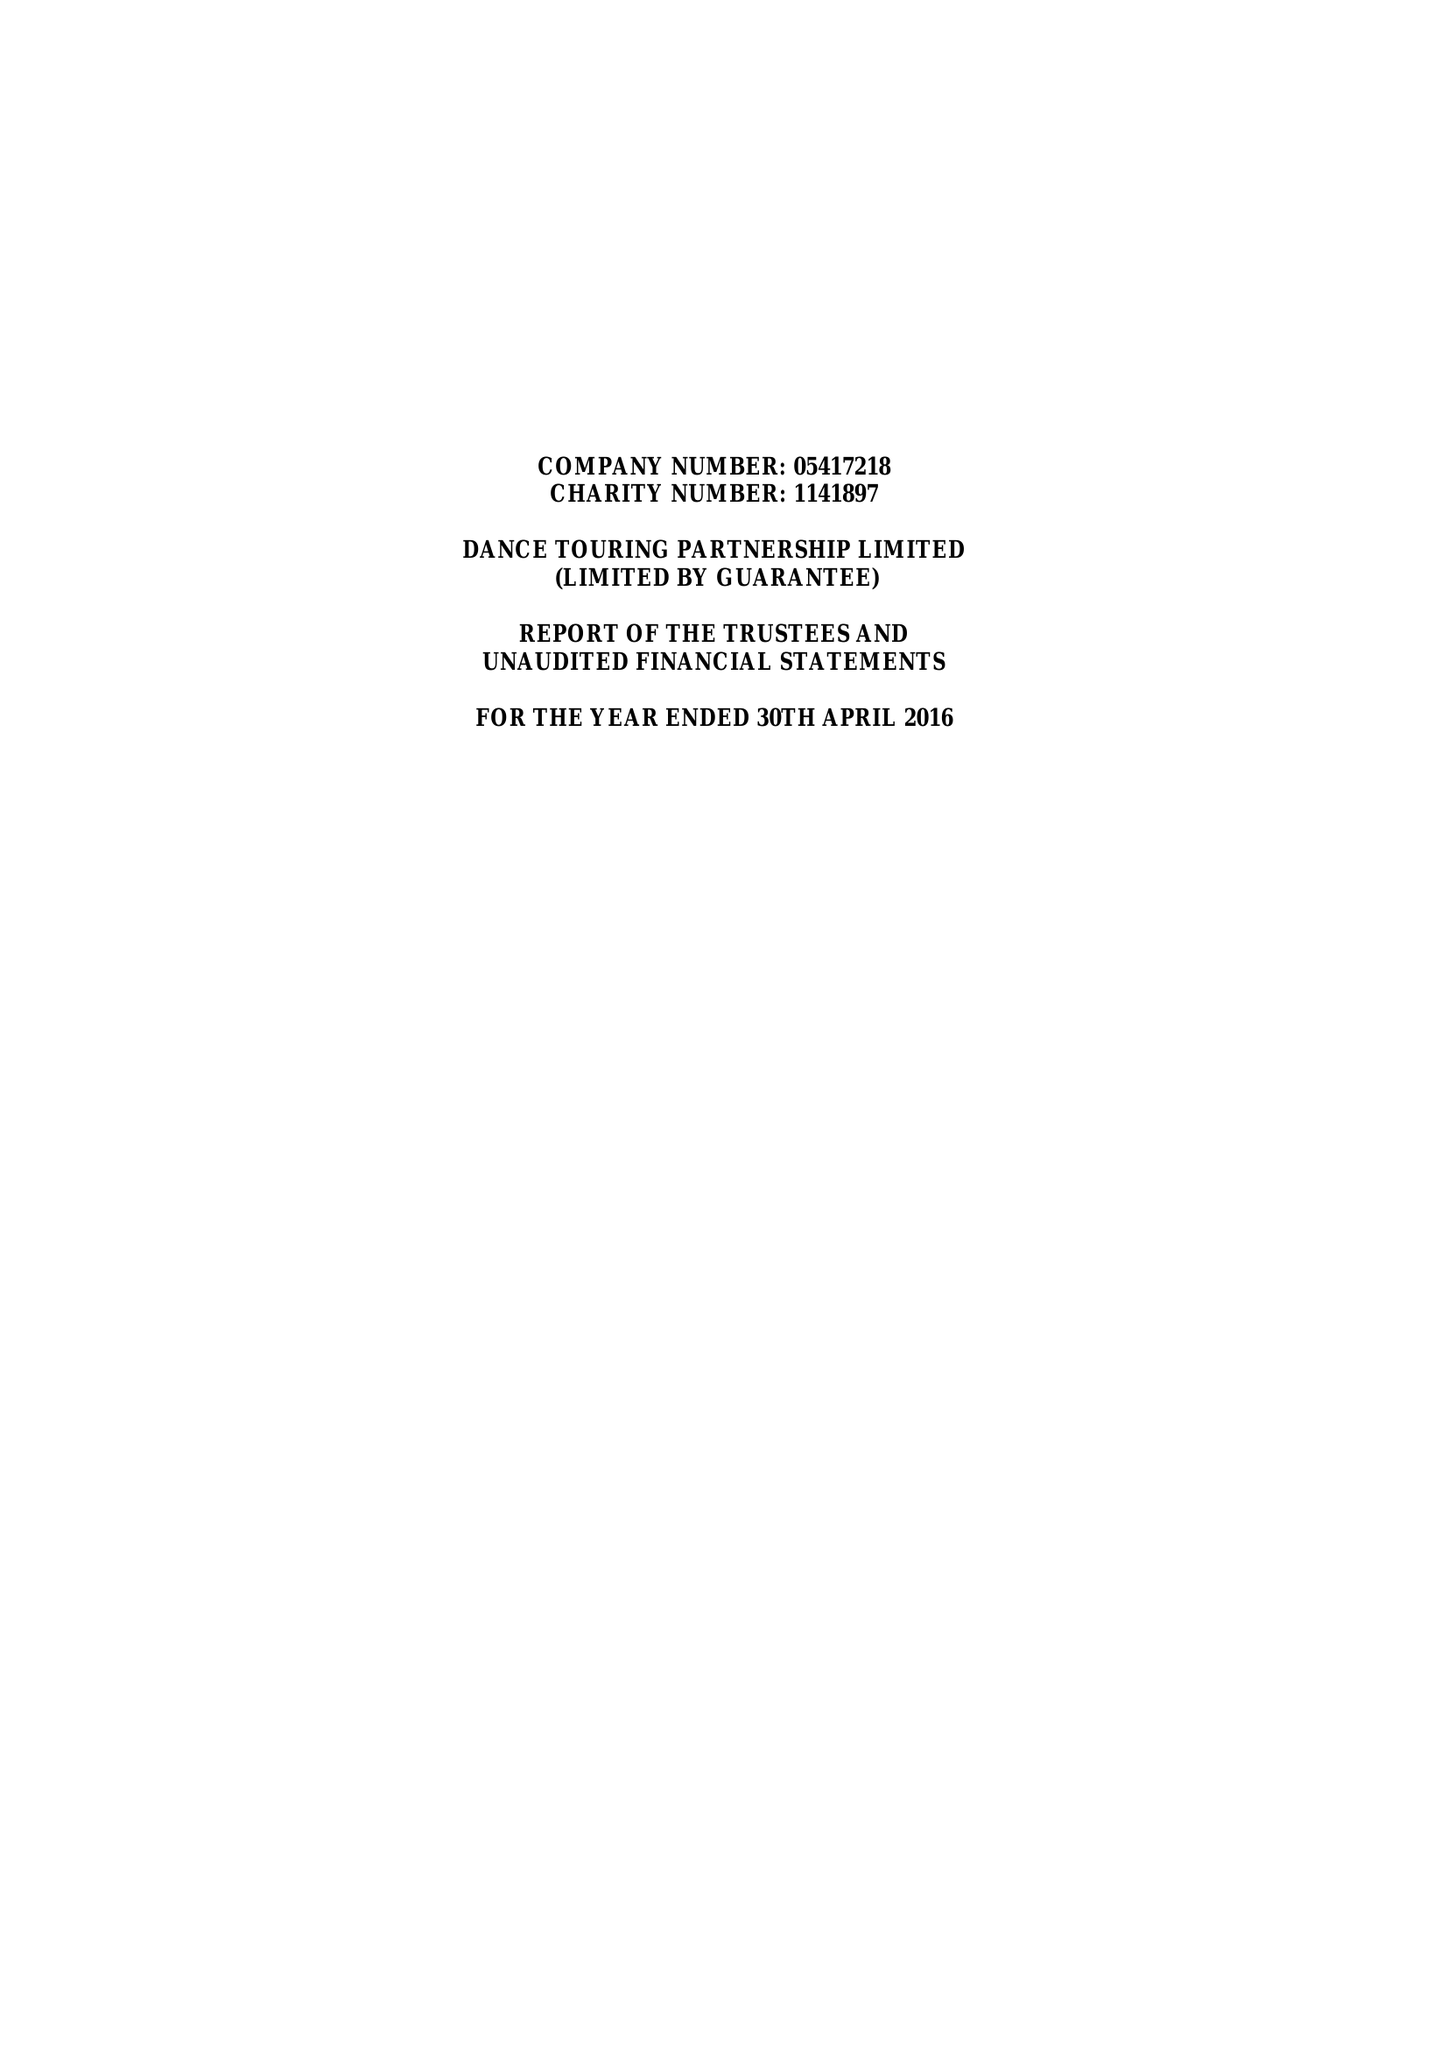What is the value for the address__post_town?
Answer the question using a single word or phrase. SHEFFIELD 